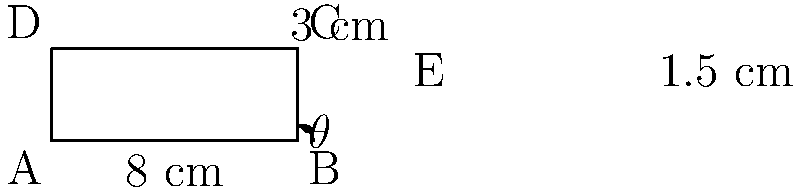You're organizing a new makeup palette storage system. The palette case measures 8 cm wide and 3 cm tall. To maximize space efficiency, you want to create two rows of palettes within the case. If the top row needs to be 1.5 cm tall, what angle $\theta$ should the divider be set at to perfectly fit both rows? To solve this problem, we'll use trigonometry. Let's approach this step-by-step:

1) We have a right triangle formed by the divider and the base of the case.

2) We know:
   - The base (adjacent side) is 8 cm
   - The height of the top row (opposite side) is 1.5 cm

3) We need to find the angle $\theta$. In a right triangle, the tangent of an angle is the ratio of the opposite side to the adjacent side.

4) Using the tangent function:

   $$\tan(\theta) = \frac{\text{opposite}}{\text{adjacent}} = \frac{1.5}{8}$$

5) To find $\theta$, we need to use the inverse tangent (arctan or $\tan^{-1}$):

   $$\theta = \tan^{-1}(\frac{1.5}{8})$$

6) Using a calculator or computer:

   $$\theta \approx 10.62^{\circ}$$

Therefore, the divider should be set at an angle of approximately 10.62 degrees to perfectly fit both rows in the makeup palette case.
Answer: $10.62^{\circ}$ 